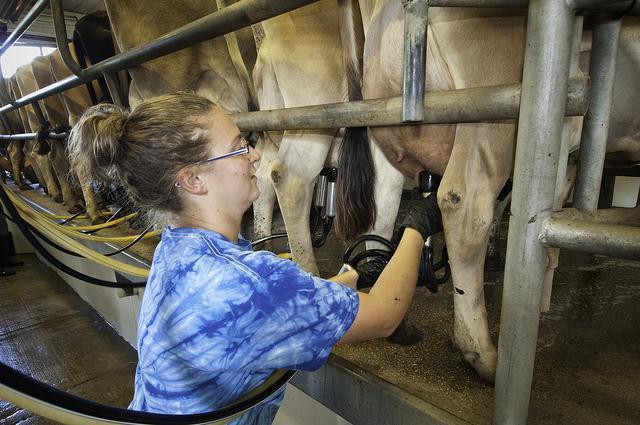How many cows are in the photo?
Give a very brief answer. 6. 